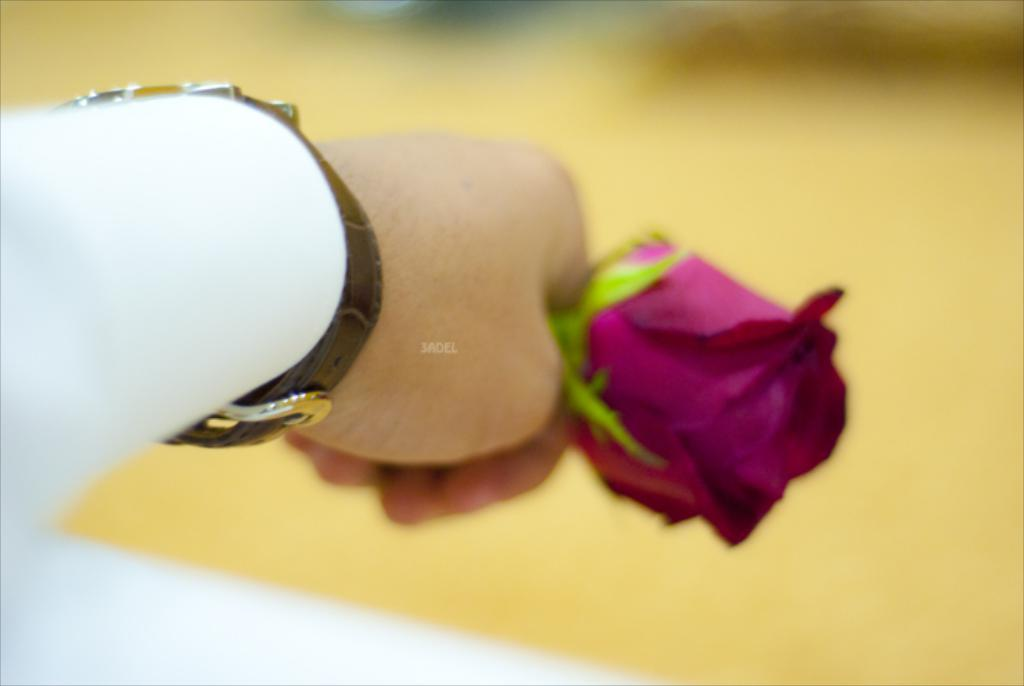What is located on the left side of the image? There is a person on the left side of the image. What is the person wearing? The person is wearing a white color shirt. What accessory can be seen on the person's wrist? The person is wearing a watch. What object is the person holding? The person is holding a rose flower. How would you describe the background of the image? The background of the image is blurred. How much fuel is needed to power the argument in the image? There is no argument present in the image, and therefore no fuel is needed to power it. 